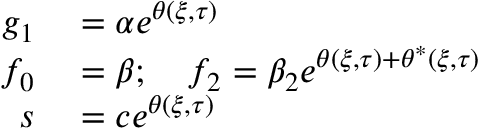Convert formula to latex. <formula><loc_0><loc_0><loc_500><loc_500>\begin{array} { r l } { g _ { 1 } } & = \alpha e ^ { \theta ( \xi , \tau ) } } \\ { f _ { 0 } } & = \beta ; \quad f _ { 2 } = \beta _ { 2 } e ^ { \theta ( \xi , \tau ) + \theta ^ { * } ( \xi , \tau ) } } \\ { s } & = c e ^ { \theta ( \xi , \tau ) } } \end{array}</formula> 